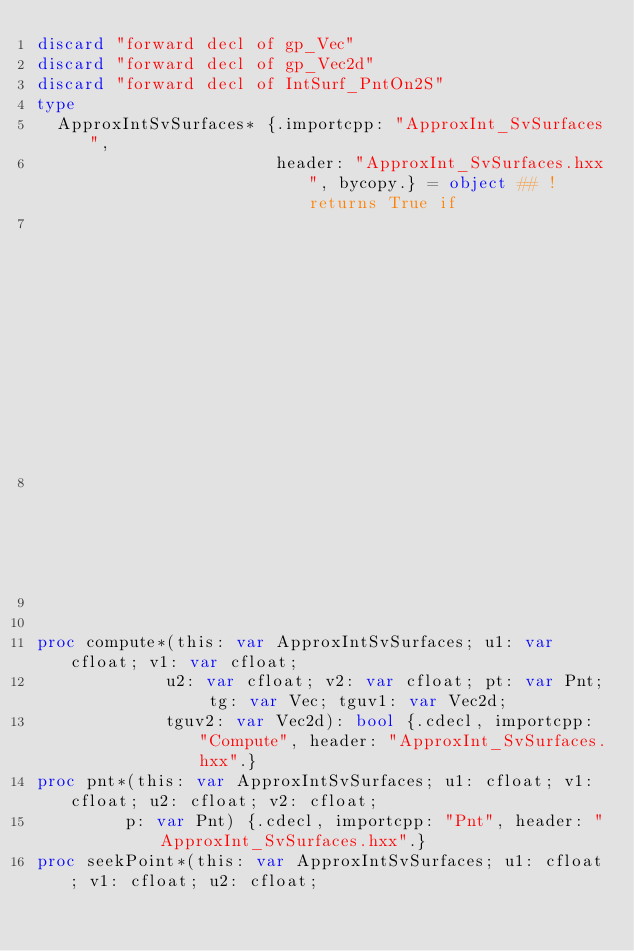Convert code to text. <code><loc_0><loc_0><loc_500><loc_500><_Nim_>discard "forward decl of gp_Vec"
discard "forward decl of gp_Vec2d"
discard "forward decl of IntSurf_PntOn2S"
type
  ApproxIntSvSurfaces* {.importcpp: "ApproxInt_SvSurfaces",
                        header: "ApproxInt_SvSurfaces.hxx", bycopy.} = object ## ! returns True if
                                                                         ## Tg,Tguv1 Tguv2 can be
                                                                         ## computed.


proc compute*(this: var ApproxIntSvSurfaces; u1: var cfloat; v1: var cfloat;
             u2: var cfloat; v2: var cfloat; pt: var Pnt; tg: var Vec; tguv1: var Vec2d;
             tguv2: var Vec2d): bool {.cdecl, importcpp: "Compute", header: "ApproxInt_SvSurfaces.hxx".}
proc pnt*(this: var ApproxIntSvSurfaces; u1: cfloat; v1: cfloat; u2: cfloat; v2: cfloat;
         p: var Pnt) {.cdecl, importcpp: "Pnt", header: "ApproxInt_SvSurfaces.hxx".}
proc seekPoint*(this: var ApproxIntSvSurfaces; u1: cfloat; v1: cfloat; u2: cfloat;</code> 